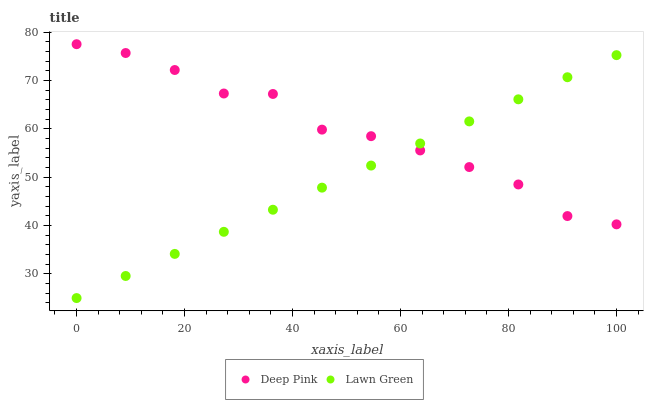Does Lawn Green have the minimum area under the curve?
Answer yes or no. Yes. Does Deep Pink have the maximum area under the curve?
Answer yes or no. Yes. Does Deep Pink have the minimum area under the curve?
Answer yes or no. No. Is Lawn Green the smoothest?
Answer yes or no. Yes. Is Deep Pink the roughest?
Answer yes or no. Yes. Is Deep Pink the smoothest?
Answer yes or no. No. Does Lawn Green have the lowest value?
Answer yes or no. Yes. Does Deep Pink have the lowest value?
Answer yes or no. No. Does Deep Pink have the highest value?
Answer yes or no. Yes. Does Lawn Green intersect Deep Pink?
Answer yes or no. Yes. Is Lawn Green less than Deep Pink?
Answer yes or no. No. Is Lawn Green greater than Deep Pink?
Answer yes or no. No. 